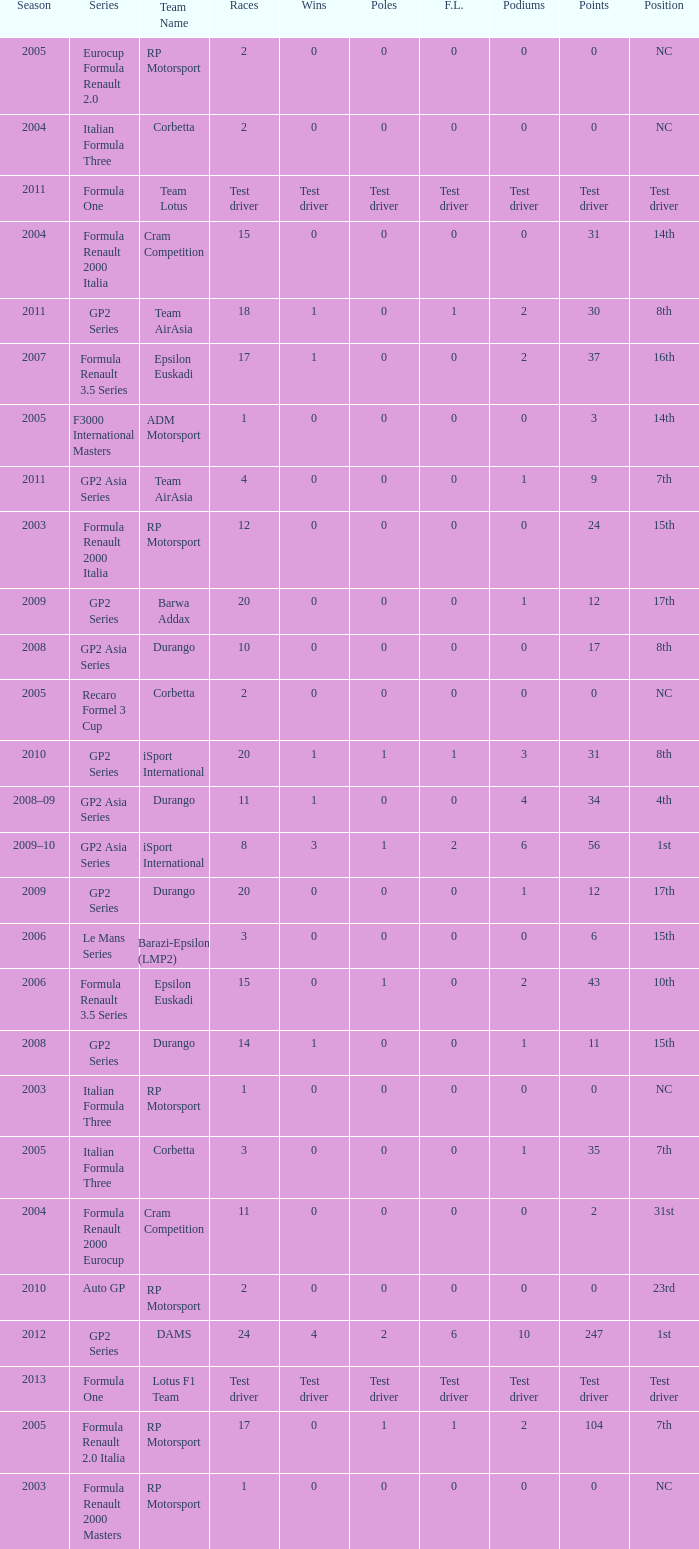What races have gp2 series, 0 F.L. and a 17th position? 20, 20. 